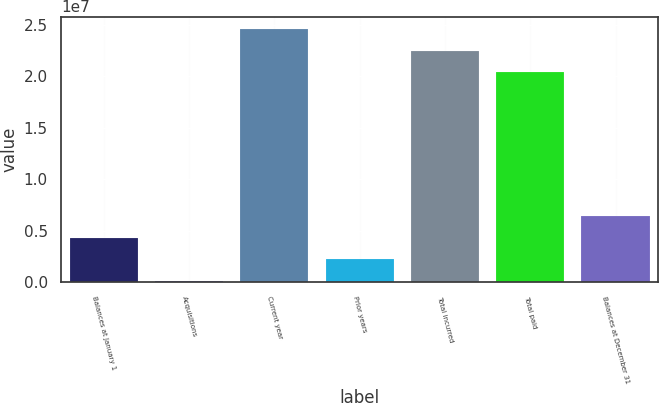<chart> <loc_0><loc_0><loc_500><loc_500><bar_chart><fcel>Balances at January 1<fcel>Acquisitions<fcel>Current year<fcel>Prior years<fcel>Total incurred<fcel>Total paid<fcel>Balances at December 31<nl><fcel>4.29524e+06<fcel>96021<fcel>2.4576e+07<fcel>2.19563e+06<fcel>2.24764e+07<fcel>2.03768e+07<fcel>6.39486e+06<nl></chart> 